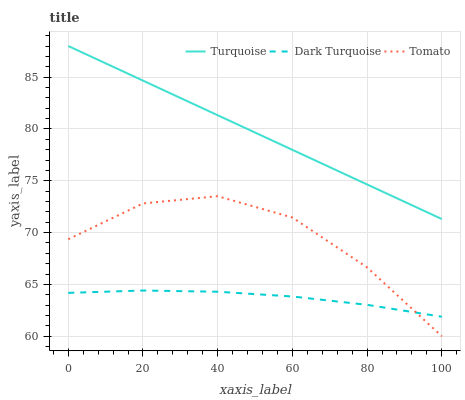Does Dark Turquoise have the minimum area under the curve?
Answer yes or no. Yes. Does Turquoise have the maximum area under the curve?
Answer yes or no. Yes. Does Turquoise have the minimum area under the curve?
Answer yes or no. No. Does Dark Turquoise have the maximum area under the curve?
Answer yes or no. No. Is Turquoise the smoothest?
Answer yes or no. Yes. Is Tomato the roughest?
Answer yes or no. Yes. Is Dark Turquoise the smoothest?
Answer yes or no. No. Is Dark Turquoise the roughest?
Answer yes or no. No. Does Tomato have the lowest value?
Answer yes or no. Yes. Does Dark Turquoise have the lowest value?
Answer yes or no. No. Does Turquoise have the highest value?
Answer yes or no. Yes. Does Dark Turquoise have the highest value?
Answer yes or no. No. Is Dark Turquoise less than Turquoise?
Answer yes or no. Yes. Is Turquoise greater than Dark Turquoise?
Answer yes or no. Yes. Does Dark Turquoise intersect Tomato?
Answer yes or no. Yes. Is Dark Turquoise less than Tomato?
Answer yes or no. No. Is Dark Turquoise greater than Tomato?
Answer yes or no. No. Does Dark Turquoise intersect Turquoise?
Answer yes or no. No. 